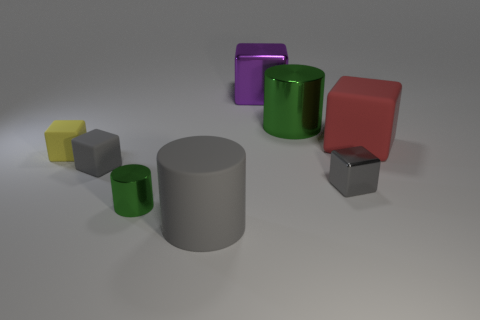Is the number of red objects right of the tiny yellow thing greater than the number of metal cylinders behind the purple thing?
Offer a very short reply. Yes. Does the small block that is on the right side of the small green metal cylinder have the same color as the matte cylinder?
Keep it short and to the point. Yes. Is there anything else that has the same color as the large shiny cylinder?
Ensure brevity in your answer.  Yes. Are there more small gray matte blocks to the right of the large matte cube than big brown matte blocks?
Provide a succinct answer. No. Is the red matte cube the same size as the purple object?
Provide a succinct answer. Yes. What material is the red thing that is the same shape as the yellow thing?
Your answer should be very brief. Rubber. Is there any other thing that has the same material as the large purple cube?
Offer a terse response. Yes. How many brown objects are either small metal cylinders or small rubber blocks?
Ensure brevity in your answer.  0. What is the material of the big cylinder that is in front of the small green shiny thing?
Your answer should be compact. Rubber. Is the number of gray objects greater than the number of cubes?
Make the answer very short. No. 